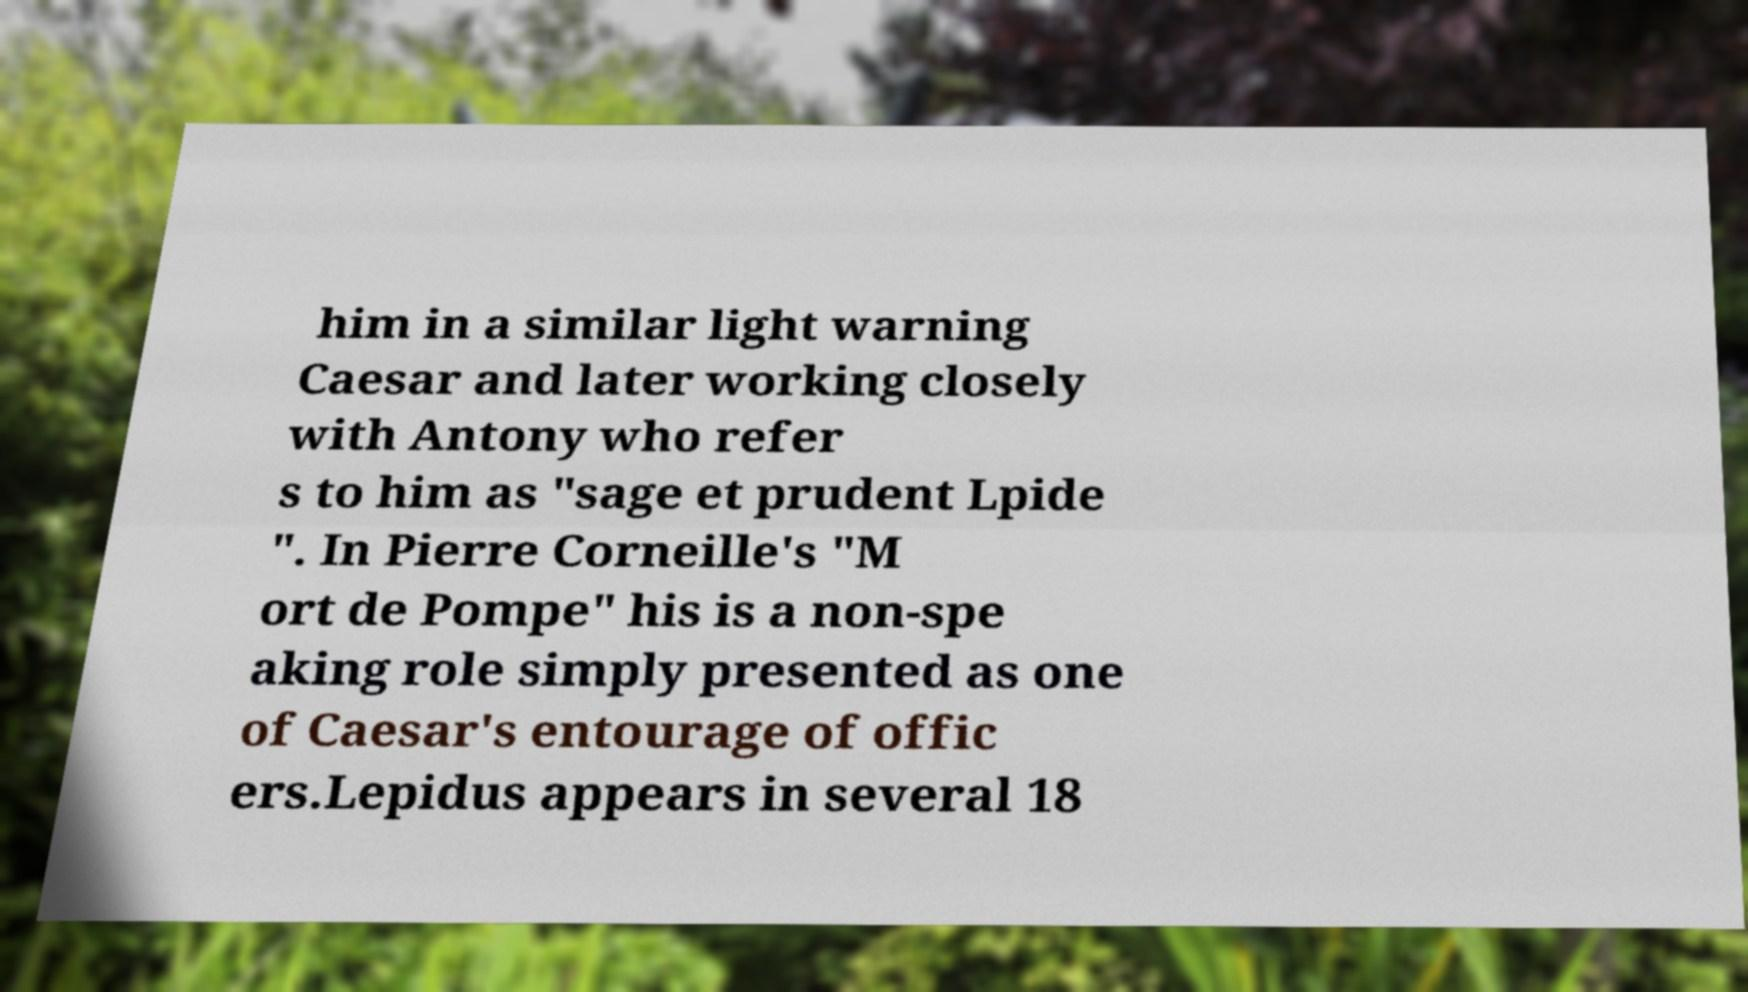I need the written content from this picture converted into text. Can you do that? him in a similar light warning Caesar and later working closely with Antony who refer s to him as "sage et prudent Lpide ". In Pierre Corneille's "M ort de Pompe" his is a non-spe aking role simply presented as one of Caesar's entourage of offic ers.Lepidus appears in several 18 